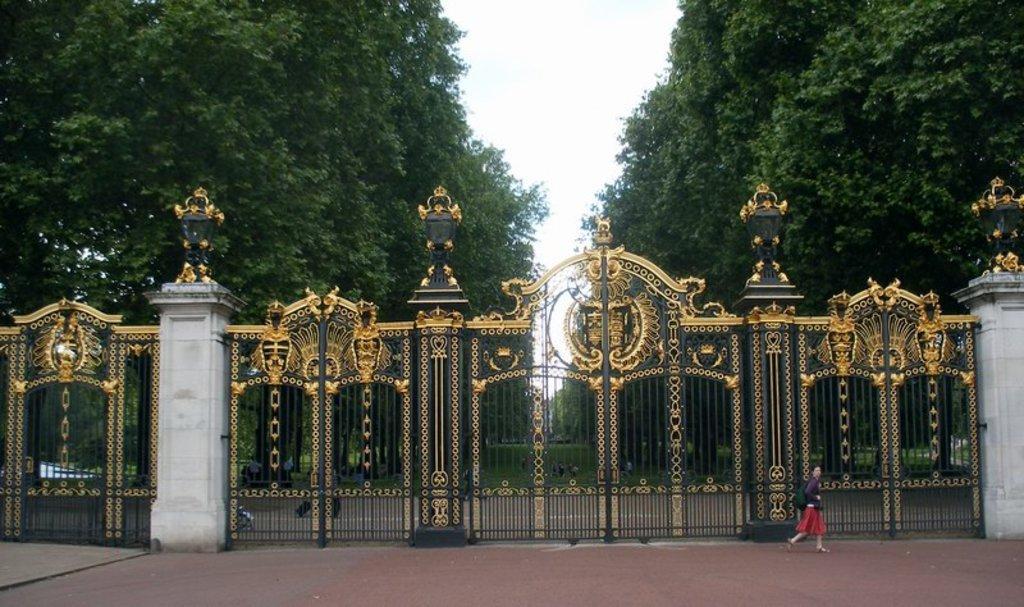How would you summarize this image in a sentence or two? In this image we can see a person with backpack is walking on the road and there is a big gate here. In the background, we can see grass, trees on the either side and the sky. 